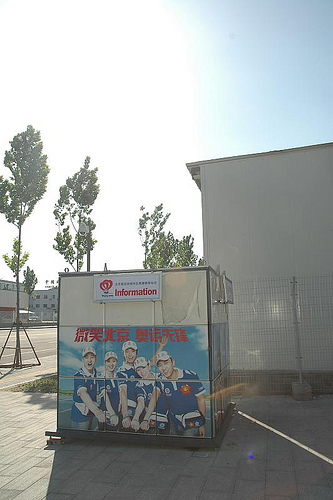<image>
Can you confirm if the tree is in front of the sky? No. The tree is not in front of the sky. The spatial positioning shows a different relationship between these objects. 